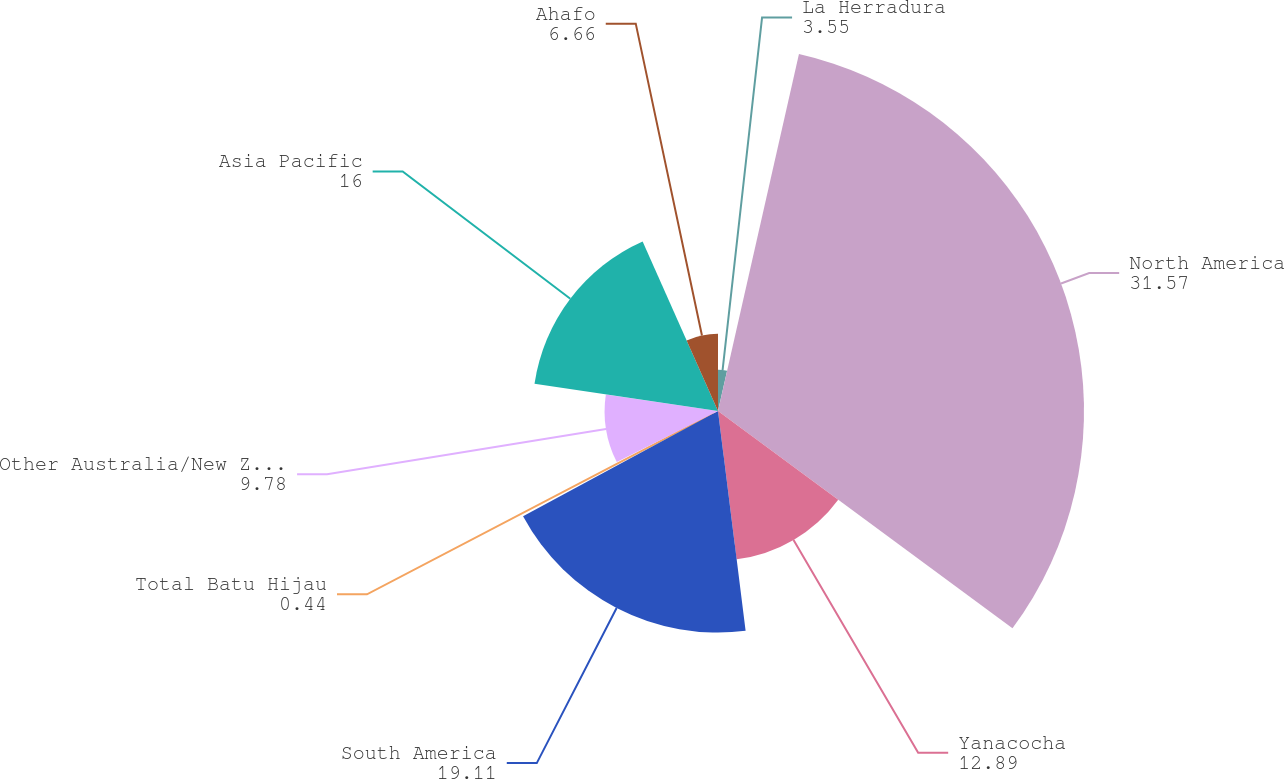Convert chart to OTSL. <chart><loc_0><loc_0><loc_500><loc_500><pie_chart><fcel>La Herradura<fcel>North America<fcel>Yanacocha<fcel>South America<fcel>Total Batu Hijau<fcel>Other Australia/New Zealand<fcel>Asia Pacific<fcel>Ahafo<nl><fcel>3.55%<fcel>31.57%<fcel>12.89%<fcel>19.11%<fcel>0.44%<fcel>9.78%<fcel>16.0%<fcel>6.66%<nl></chart> 